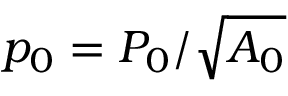<formula> <loc_0><loc_0><loc_500><loc_500>p _ { 0 } = P _ { 0 } / \sqrt { A _ { 0 } }</formula> 